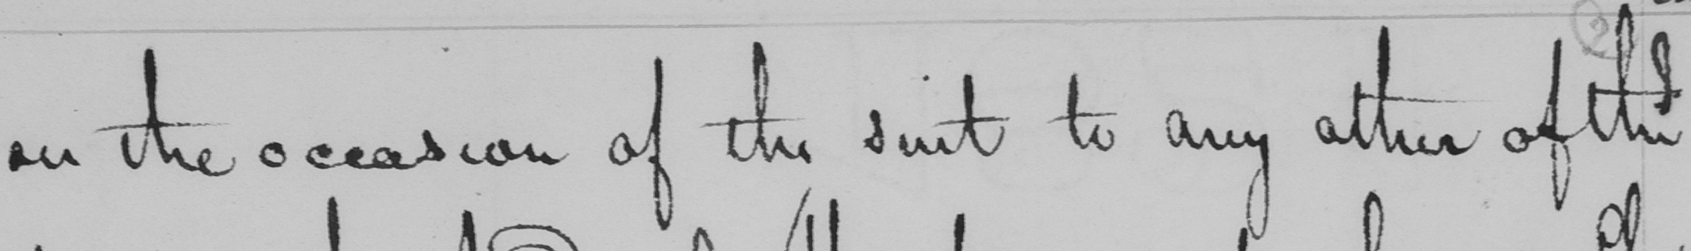What is written in this line of handwriting? on the occasion of this suit to any other of the 